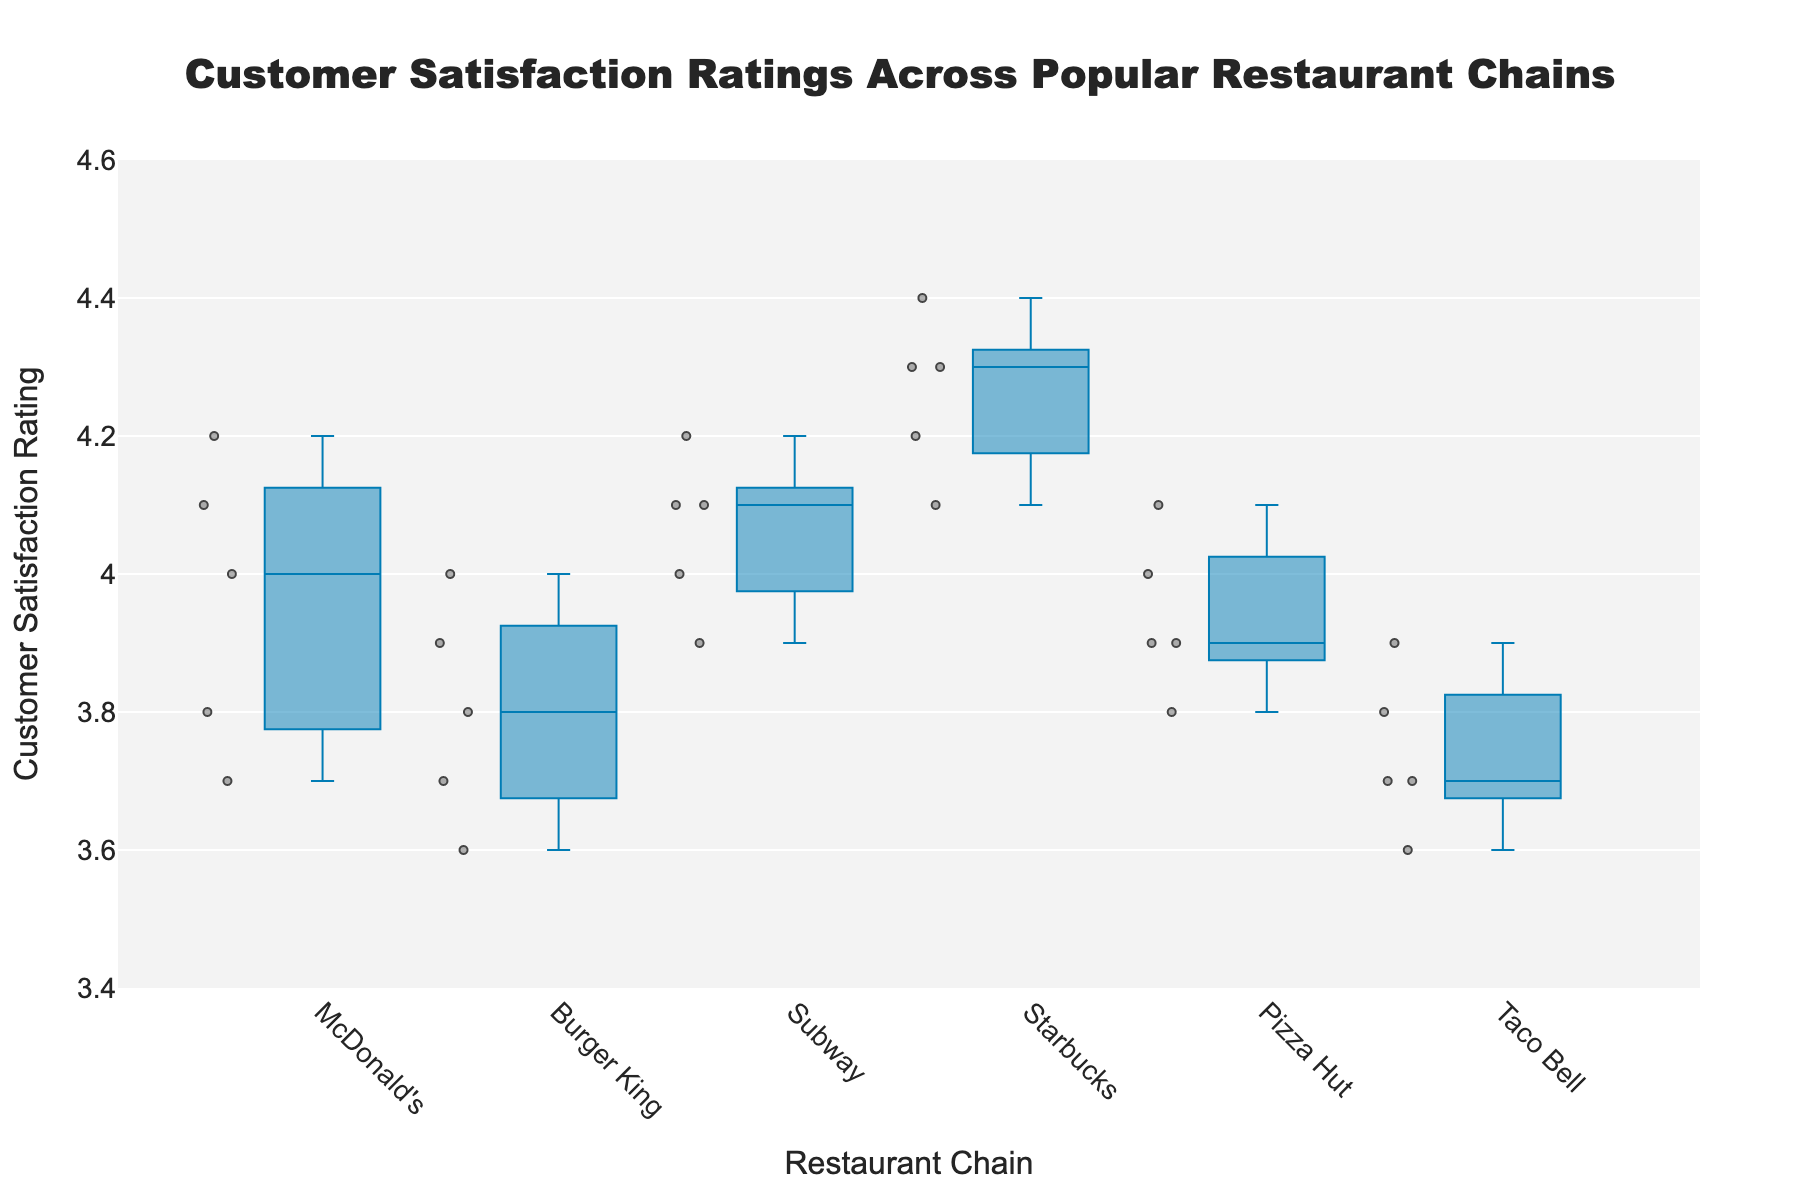Which restaurant chain has the highest median customer satisfaction rating? The median is the middle value when the data points are ordered from lowest to highest. Observing the box plot, the middle line inside the box represents the median. In this case, Starbucks has the highest median rating.
Answer: Starbucks Which restaurant chains have the lowest median customer satisfaction ratings? The median is represented by the line within the box in the box plot. The lowest median ratings appear in the chains where this line is the lowest. Here, both McDonald’s and Taco Bell have the lowest medians.
Answer: McDonald’s, Taco Bell What is the range of customer satisfaction ratings for Subway? The range is the difference between the highest and lowest values. Observing the Subway box plot, the upper whisker ends at 4.2 and the lower whisker just below 3.9. So, 4.2 - 3.9 = 0.3.
Answer: 0.3 Compare the spread of ratings between Pizza Hut and Burger King. Which one has a wider spread? The spread of a box plot is indicated by the length of the box and whiskers combined. Comparing the plots, Pizza Hut’s box and whiskers spread wider vertically compared to Burger King's, indicating a larger spread.
Answer: Pizza Hut Which restaurant chain has the most consistent customer satisfaction ratings (i.e., smallest spread)? The most consistent ratings will have the shortest box and whiskers. Observing the plots, Subway has the shortest combination of box and whiskers lengths, indicating the most consistent ratings.
Answer: Subway Does any restaurant chain have outliers in their customer satisfaction ratings? Outliers, if any, are usually shown as individual points outside the whiskers. Observing the plots, none of the restaurant chains appear to have outliers represented in this figure.
Answer: No Which restaurant chains have customer satisfaction ratings falling below 3.8? Any chain with whiskers or data points below 3.8 will be considered. Taco Bell, Burger King, and McDonald's have ratings that fall below this threshold.
Answer: Taco Bell, Burger King, McDonald’s What is the average of the median customer satisfaction ratings across all the restaurant chains? First, find the median for each chain: McDonald's (4.0), Burger King (3.9), Subway (4.1), Starbucks (4.3), Pizza Hut (4.0), and Taco Bell (3.8). The average is the sum of these medians divided by the number of chains: (4.0 + 3.9 + 4.1 + 4.3 + 4.0 + 3.8) / 6 = 4.02.
Answer: 4.02 Which restaurant chain's rating has the highest lower quartile (Q1)? The lower quartile (Q1) is the lower edge of the box. Observing the plots, Starbucks has the highest lower quartile.
Answer: Starbucks 